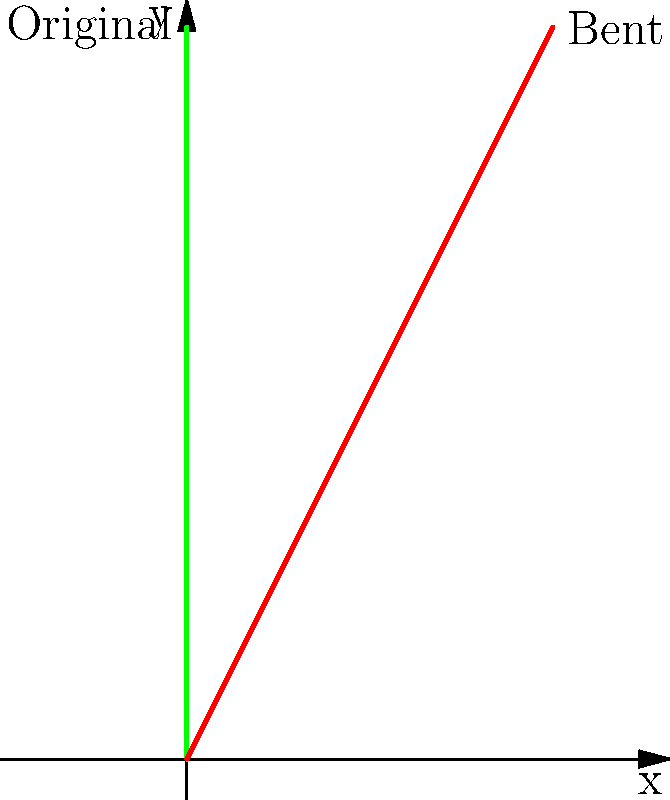A Hypericum stem is modeled as a straight line from $(0,0)$ to $(0,4)$ in a coordinate system where the y-axis represents the vertical direction. Under certain environmental conditions, the stem bends, which can be represented by a shear transformation. If the shear factor $k = 0.5$ is applied parallel to the x-axis, what are the coordinates of the tip of the bent stem? To solve this problem, we need to apply the shear transformation to the original stem:

1) The original stem extends from $(0,0)$ to $(0,4)$.

2) A shear transformation parallel to the x-axis with factor $k$ is represented by the matrix:
   $$\begin{pmatrix} 1 & k \\ 0 & 1 \end{pmatrix}$$

3) Applying this transformation to the point $(0,4)$:
   $$\begin{pmatrix} 1 & 0.5 \\ 0 & 1 \end{pmatrix} \begin{pmatrix} 0 \\ 4 \end{pmatrix} = \begin{pmatrix} 0.5 \cdot 4 \\ 4 \end{pmatrix} = \begin{pmatrix} 2 \\ 4 \end{pmatrix}$$

4) Therefore, the tip of the bent stem moves from $(0,4)$ to $(2,4)$.

This transformation represents how the Hypericum stem might bend under environmental stresses such as wind or uneven sunlight, while maintaining its length.
Answer: $(2,4)$ 